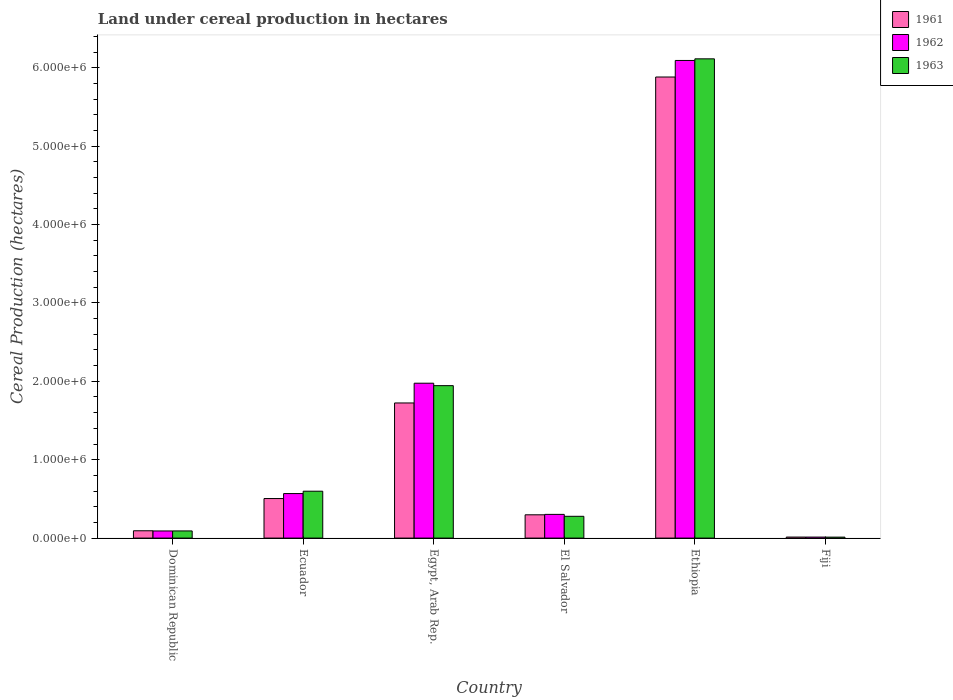How many different coloured bars are there?
Give a very brief answer. 3. Are the number of bars per tick equal to the number of legend labels?
Provide a succinct answer. Yes. Are the number of bars on each tick of the X-axis equal?
Give a very brief answer. Yes. How many bars are there on the 3rd tick from the right?
Provide a succinct answer. 3. What is the label of the 4th group of bars from the left?
Ensure brevity in your answer.  El Salvador. In how many cases, is the number of bars for a given country not equal to the number of legend labels?
Your answer should be compact. 0. What is the land under cereal production in 1963 in Ecuador?
Keep it short and to the point. 5.98e+05. Across all countries, what is the maximum land under cereal production in 1962?
Ensure brevity in your answer.  6.09e+06. Across all countries, what is the minimum land under cereal production in 1961?
Offer a very short reply. 1.31e+04. In which country was the land under cereal production in 1961 maximum?
Provide a short and direct response. Ethiopia. In which country was the land under cereal production in 1963 minimum?
Offer a terse response. Fiji. What is the total land under cereal production in 1963 in the graph?
Keep it short and to the point. 9.04e+06. What is the difference between the land under cereal production in 1963 in Dominican Republic and that in El Salvador?
Your answer should be very brief. -1.86e+05. What is the difference between the land under cereal production in 1961 in Ecuador and the land under cereal production in 1963 in El Salvador?
Offer a very short reply. 2.27e+05. What is the average land under cereal production in 1963 per country?
Offer a very short reply. 1.51e+06. What is the difference between the land under cereal production of/in 1961 and land under cereal production of/in 1962 in Ethiopia?
Ensure brevity in your answer.  -2.11e+05. In how many countries, is the land under cereal production in 1962 greater than 5000000 hectares?
Offer a terse response. 1. What is the ratio of the land under cereal production in 1963 in Egypt, Arab Rep. to that in El Salvador?
Give a very brief answer. 7. Is the land under cereal production in 1962 in Dominican Republic less than that in Egypt, Arab Rep.?
Provide a succinct answer. Yes. What is the difference between the highest and the second highest land under cereal production in 1963?
Your answer should be compact. -1.35e+06. What is the difference between the highest and the lowest land under cereal production in 1963?
Keep it short and to the point. 6.10e+06. Is the sum of the land under cereal production in 1962 in Ecuador and El Salvador greater than the maximum land under cereal production in 1961 across all countries?
Provide a short and direct response. No. How many countries are there in the graph?
Ensure brevity in your answer.  6. Does the graph contain grids?
Your response must be concise. No. Where does the legend appear in the graph?
Your answer should be compact. Top right. What is the title of the graph?
Your answer should be compact. Land under cereal production in hectares. Does "1985" appear as one of the legend labels in the graph?
Keep it short and to the point. No. What is the label or title of the Y-axis?
Ensure brevity in your answer.  Cereal Production (hectares). What is the Cereal Production (hectares) of 1961 in Dominican Republic?
Provide a succinct answer. 9.33e+04. What is the Cereal Production (hectares) in 1962 in Dominican Republic?
Give a very brief answer. 9.10e+04. What is the Cereal Production (hectares) of 1963 in Dominican Republic?
Your answer should be compact. 9.14e+04. What is the Cereal Production (hectares) in 1961 in Ecuador?
Keep it short and to the point. 5.05e+05. What is the Cereal Production (hectares) of 1962 in Ecuador?
Ensure brevity in your answer.  5.68e+05. What is the Cereal Production (hectares) of 1963 in Ecuador?
Offer a terse response. 5.98e+05. What is the Cereal Production (hectares) of 1961 in Egypt, Arab Rep.?
Ensure brevity in your answer.  1.72e+06. What is the Cereal Production (hectares) in 1962 in Egypt, Arab Rep.?
Ensure brevity in your answer.  1.98e+06. What is the Cereal Production (hectares) in 1963 in Egypt, Arab Rep.?
Offer a terse response. 1.94e+06. What is the Cereal Production (hectares) in 1961 in El Salvador?
Your response must be concise. 2.97e+05. What is the Cereal Production (hectares) of 1962 in El Salvador?
Offer a very short reply. 3.02e+05. What is the Cereal Production (hectares) in 1963 in El Salvador?
Your answer should be very brief. 2.78e+05. What is the Cereal Production (hectares) in 1961 in Ethiopia?
Your answer should be compact. 5.88e+06. What is the Cereal Production (hectares) in 1962 in Ethiopia?
Keep it short and to the point. 6.09e+06. What is the Cereal Production (hectares) in 1963 in Ethiopia?
Make the answer very short. 6.11e+06. What is the Cereal Production (hectares) of 1961 in Fiji?
Your answer should be compact. 1.31e+04. What is the Cereal Production (hectares) of 1962 in Fiji?
Offer a terse response. 1.29e+04. What is the Cereal Production (hectares) in 1963 in Fiji?
Your answer should be very brief. 1.23e+04. Across all countries, what is the maximum Cereal Production (hectares) in 1961?
Offer a very short reply. 5.88e+06. Across all countries, what is the maximum Cereal Production (hectares) of 1962?
Offer a terse response. 6.09e+06. Across all countries, what is the maximum Cereal Production (hectares) of 1963?
Your answer should be compact. 6.11e+06. Across all countries, what is the minimum Cereal Production (hectares) of 1961?
Your response must be concise. 1.31e+04. Across all countries, what is the minimum Cereal Production (hectares) in 1962?
Make the answer very short. 1.29e+04. Across all countries, what is the minimum Cereal Production (hectares) of 1963?
Give a very brief answer. 1.23e+04. What is the total Cereal Production (hectares) of 1961 in the graph?
Offer a terse response. 8.51e+06. What is the total Cereal Production (hectares) in 1962 in the graph?
Offer a terse response. 9.04e+06. What is the total Cereal Production (hectares) of 1963 in the graph?
Your response must be concise. 9.04e+06. What is the difference between the Cereal Production (hectares) of 1961 in Dominican Republic and that in Ecuador?
Give a very brief answer. -4.11e+05. What is the difference between the Cereal Production (hectares) of 1962 in Dominican Republic and that in Ecuador?
Offer a very short reply. -4.77e+05. What is the difference between the Cereal Production (hectares) of 1963 in Dominican Republic and that in Ecuador?
Your answer should be compact. -5.07e+05. What is the difference between the Cereal Production (hectares) in 1961 in Dominican Republic and that in Egypt, Arab Rep.?
Provide a succinct answer. -1.63e+06. What is the difference between the Cereal Production (hectares) of 1962 in Dominican Republic and that in Egypt, Arab Rep.?
Keep it short and to the point. -1.88e+06. What is the difference between the Cereal Production (hectares) in 1963 in Dominican Republic and that in Egypt, Arab Rep.?
Keep it short and to the point. -1.85e+06. What is the difference between the Cereal Production (hectares) in 1961 in Dominican Republic and that in El Salvador?
Your response must be concise. -2.04e+05. What is the difference between the Cereal Production (hectares) in 1962 in Dominican Republic and that in El Salvador?
Your answer should be very brief. -2.11e+05. What is the difference between the Cereal Production (hectares) of 1963 in Dominican Republic and that in El Salvador?
Offer a terse response. -1.86e+05. What is the difference between the Cereal Production (hectares) in 1961 in Dominican Republic and that in Ethiopia?
Ensure brevity in your answer.  -5.79e+06. What is the difference between the Cereal Production (hectares) in 1962 in Dominican Republic and that in Ethiopia?
Provide a succinct answer. -6.00e+06. What is the difference between the Cereal Production (hectares) of 1963 in Dominican Republic and that in Ethiopia?
Ensure brevity in your answer.  -6.02e+06. What is the difference between the Cereal Production (hectares) of 1961 in Dominican Republic and that in Fiji?
Your answer should be very brief. 8.03e+04. What is the difference between the Cereal Production (hectares) in 1962 in Dominican Republic and that in Fiji?
Make the answer very short. 7.81e+04. What is the difference between the Cereal Production (hectares) of 1963 in Dominican Republic and that in Fiji?
Provide a succinct answer. 7.91e+04. What is the difference between the Cereal Production (hectares) in 1961 in Ecuador and that in Egypt, Arab Rep.?
Your response must be concise. -1.22e+06. What is the difference between the Cereal Production (hectares) of 1962 in Ecuador and that in Egypt, Arab Rep.?
Provide a short and direct response. -1.41e+06. What is the difference between the Cereal Production (hectares) of 1963 in Ecuador and that in Egypt, Arab Rep.?
Offer a terse response. -1.35e+06. What is the difference between the Cereal Production (hectares) in 1961 in Ecuador and that in El Salvador?
Your answer should be very brief. 2.07e+05. What is the difference between the Cereal Production (hectares) in 1962 in Ecuador and that in El Salvador?
Your answer should be very brief. 2.66e+05. What is the difference between the Cereal Production (hectares) in 1963 in Ecuador and that in El Salvador?
Make the answer very short. 3.20e+05. What is the difference between the Cereal Production (hectares) in 1961 in Ecuador and that in Ethiopia?
Provide a succinct answer. -5.38e+06. What is the difference between the Cereal Production (hectares) in 1962 in Ecuador and that in Ethiopia?
Provide a succinct answer. -5.53e+06. What is the difference between the Cereal Production (hectares) of 1963 in Ecuador and that in Ethiopia?
Ensure brevity in your answer.  -5.52e+06. What is the difference between the Cereal Production (hectares) in 1961 in Ecuador and that in Fiji?
Provide a short and direct response. 4.91e+05. What is the difference between the Cereal Production (hectares) of 1962 in Ecuador and that in Fiji?
Give a very brief answer. 5.55e+05. What is the difference between the Cereal Production (hectares) of 1963 in Ecuador and that in Fiji?
Provide a succinct answer. 5.86e+05. What is the difference between the Cereal Production (hectares) of 1961 in Egypt, Arab Rep. and that in El Salvador?
Your response must be concise. 1.43e+06. What is the difference between the Cereal Production (hectares) in 1962 in Egypt, Arab Rep. and that in El Salvador?
Your answer should be very brief. 1.67e+06. What is the difference between the Cereal Production (hectares) in 1963 in Egypt, Arab Rep. and that in El Salvador?
Your answer should be very brief. 1.67e+06. What is the difference between the Cereal Production (hectares) of 1961 in Egypt, Arab Rep. and that in Ethiopia?
Your answer should be compact. -4.16e+06. What is the difference between the Cereal Production (hectares) of 1962 in Egypt, Arab Rep. and that in Ethiopia?
Your answer should be very brief. -4.12e+06. What is the difference between the Cereal Production (hectares) of 1963 in Egypt, Arab Rep. and that in Ethiopia?
Keep it short and to the point. -4.17e+06. What is the difference between the Cereal Production (hectares) of 1961 in Egypt, Arab Rep. and that in Fiji?
Ensure brevity in your answer.  1.71e+06. What is the difference between the Cereal Production (hectares) in 1962 in Egypt, Arab Rep. and that in Fiji?
Ensure brevity in your answer.  1.96e+06. What is the difference between the Cereal Production (hectares) in 1963 in Egypt, Arab Rep. and that in Fiji?
Keep it short and to the point. 1.93e+06. What is the difference between the Cereal Production (hectares) in 1961 in El Salvador and that in Ethiopia?
Ensure brevity in your answer.  -5.58e+06. What is the difference between the Cereal Production (hectares) of 1962 in El Salvador and that in Ethiopia?
Your answer should be very brief. -5.79e+06. What is the difference between the Cereal Production (hectares) of 1963 in El Salvador and that in Ethiopia?
Your answer should be compact. -5.84e+06. What is the difference between the Cereal Production (hectares) of 1961 in El Salvador and that in Fiji?
Your response must be concise. 2.84e+05. What is the difference between the Cereal Production (hectares) in 1962 in El Salvador and that in Fiji?
Offer a very short reply. 2.90e+05. What is the difference between the Cereal Production (hectares) of 1963 in El Salvador and that in Fiji?
Provide a succinct answer. 2.66e+05. What is the difference between the Cereal Production (hectares) of 1961 in Ethiopia and that in Fiji?
Your answer should be very brief. 5.87e+06. What is the difference between the Cereal Production (hectares) of 1962 in Ethiopia and that in Fiji?
Ensure brevity in your answer.  6.08e+06. What is the difference between the Cereal Production (hectares) of 1963 in Ethiopia and that in Fiji?
Your response must be concise. 6.10e+06. What is the difference between the Cereal Production (hectares) in 1961 in Dominican Republic and the Cereal Production (hectares) in 1962 in Ecuador?
Provide a short and direct response. -4.75e+05. What is the difference between the Cereal Production (hectares) in 1961 in Dominican Republic and the Cereal Production (hectares) in 1963 in Ecuador?
Offer a terse response. -5.05e+05. What is the difference between the Cereal Production (hectares) of 1962 in Dominican Republic and the Cereal Production (hectares) of 1963 in Ecuador?
Make the answer very short. -5.07e+05. What is the difference between the Cereal Production (hectares) of 1961 in Dominican Republic and the Cereal Production (hectares) of 1962 in Egypt, Arab Rep.?
Provide a short and direct response. -1.88e+06. What is the difference between the Cereal Production (hectares) of 1961 in Dominican Republic and the Cereal Production (hectares) of 1963 in Egypt, Arab Rep.?
Provide a short and direct response. -1.85e+06. What is the difference between the Cereal Production (hectares) in 1962 in Dominican Republic and the Cereal Production (hectares) in 1963 in Egypt, Arab Rep.?
Your answer should be very brief. -1.85e+06. What is the difference between the Cereal Production (hectares) of 1961 in Dominican Republic and the Cereal Production (hectares) of 1962 in El Salvador?
Give a very brief answer. -2.09e+05. What is the difference between the Cereal Production (hectares) in 1961 in Dominican Republic and the Cereal Production (hectares) in 1963 in El Salvador?
Provide a succinct answer. -1.85e+05. What is the difference between the Cereal Production (hectares) of 1962 in Dominican Republic and the Cereal Production (hectares) of 1963 in El Salvador?
Offer a very short reply. -1.87e+05. What is the difference between the Cereal Production (hectares) of 1961 in Dominican Republic and the Cereal Production (hectares) of 1962 in Ethiopia?
Provide a short and direct response. -6.00e+06. What is the difference between the Cereal Production (hectares) in 1961 in Dominican Republic and the Cereal Production (hectares) in 1963 in Ethiopia?
Provide a short and direct response. -6.02e+06. What is the difference between the Cereal Production (hectares) in 1962 in Dominican Republic and the Cereal Production (hectares) in 1963 in Ethiopia?
Provide a succinct answer. -6.02e+06. What is the difference between the Cereal Production (hectares) in 1961 in Dominican Republic and the Cereal Production (hectares) in 1962 in Fiji?
Ensure brevity in your answer.  8.05e+04. What is the difference between the Cereal Production (hectares) in 1961 in Dominican Republic and the Cereal Production (hectares) in 1963 in Fiji?
Your response must be concise. 8.11e+04. What is the difference between the Cereal Production (hectares) of 1962 in Dominican Republic and the Cereal Production (hectares) of 1963 in Fiji?
Give a very brief answer. 7.87e+04. What is the difference between the Cereal Production (hectares) in 1961 in Ecuador and the Cereal Production (hectares) in 1962 in Egypt, Arab Rep.?
Make the answer very short. -1.47e+06. What is the difference between the Cereal Production (hectares) of 1961 in Ecuador and the Cereal Production (hectares) of 1963 in Egypt, Arab Rep.?
Provide a short and direct response. -1.44e+06. What is the difference between the Cereal Production (hectares) of 1962 in Ecuador and the Cereal Production (hectares) of 1963 in Egypt, Arab Rep.?
Keep it short and to the point. -1.38e+06. What is the difference between the Cereal Production (hectares) of 1961 in Ecuador and the Cereal Production (hectares) of 1962 in El Salvador?
Offer a very short reply. 2.02e+05. What is the difference between the Cereal Production (hectares) of 1961 in Ecuador and the Cereal Production (hectares) of 1963 in El Salvador?
Offer a very short reply. 2.27e+05. What is the difference between the Cereal Production (hectares) in 1962 in Ecuador and the Cereal Production (hectares) in 1963 in El Salvador?
Offer a terse response. 2.90e+05. What is the difference between the Cereal Production (hectares) in 1961 in Ecuador and the Cereal Production (hectares) in 1962 in Ethiopia?
Your answer should be very brief. -5.59e+06. What is the difference between the Cereal Production (hectares) of 1961 in Ecuador and the Cereal Production (hectares) of 1963 in Ethiopia?
Provide a succinct answer. -5.61e+06. What is the difference between the Cereal Production (hectares) of 1962 in Ecuador and the Cereal Production (hectares) of 1963 in Ethiopia?
Your answer should be very brief. -5.55e+06. What is the difference between the Cereal Production (hectares) of 1961 in Ecuador and the Cereal Production (hectares) of 1962 in Fiji?
Your response must be concise. 4.92e+05. What is the difference between the Cereal Production (hectares) of 1961 in Ecuador and the Cereal Production (hectares) of 1963 in Fiji?
Make the answer very short. 4.92e+05. What is the difference between the Cereal Production (hectares) in 1962 in Ecuador and the Cereal Production (hectares) in 1963 in Fiji?
Provide a succinct answer. 5.56e+05. What is the difference between the Cereal Production (hectares) in 1961 in Egypt, Arab Rep. and the Cereal Production (hectares) in 1962 in El Salvador?
Offer a very short reply. 1.42e+06. What is the difference between the Cereal Production (hectares) of 1961 in Egypt, Arab Rep. and the Cereal Production (hectares) of 1963 in El Salvador?
Make the answer very short. 1.45e+06. What is the difference between the Cereal Production (hectares) in 1962 in Egypt, Arab Rep. and the Cereal Production (hectares) in 1963 in El Salvador?
Offer a terse response. 1.70e+06. What is the difference between the Cereal Production (hectares) of 1961 in Egypt, Arab Rep. and the Cereal Production (hectares) of 1962 in Ethiopia?
Provide a succinct answer. -4.37e+06. What is the difference between the Cereal Production (hectares) in 1961 in Egypt, Arab Rep. and the Cereal Production (hectares) in 1963 in Ethiopia?
Offer a very short reply. -4.39e+06. What is the difference between the Cereal Production (hectares) in 1962 in Egypt, Arab Rep. and the Cereal Production (hectares) in 1963 in Ethiopia?
Offer a terse response. -4.14e+06. What is the difference between the Cereal Production (hectares) in 1961 in Egypt, Arab Rep. and the Cereal Production (hectares) in 1962 in Fiji?
Your answer should be very brief. 1.71e+06. What is the difference between the Cereal Production (hectares) of 1961 in Egypt, Arab Rep. and the Cereal Production (hectares) of 1963 in Fiji?
Your answer should be compact. 1.71e+06. What is the difference between the Cereal Production (hectares) of 1962 in Egypt, Arab Rep. and the Cereal Production (hectares) of 1963 in Fiji?
Make the answer very short. 1.96e+06. What is the difference between the Cereal Production (hectares) of 1961 in El Salvador and the Cereal Production (hectares) of 1962 in Ethiopia?
Provide a succinct answer. -5.80e+06. What is the difference between the Cereal Production (hectares) in 1961 in El Salvador and the Cereal Production (hectares) in 1963 in Ethiopia?
Give a very brief answer. -5.82e+06. What is the difference between the Cereal Production (hectares) of 1962 in El Salvador and the Cereal Production (hectares) of 1963 in Ethiopia?
Your answer should be very brief. -5.81e+06. What is the difference between the Cereal Production (hectares) of 1961 in El Salvador and the Cereal Production (hectares) of 1962 in Fiji?
Keep it short and to the point. 2.84e+05. What is the difference between the Cereal Production (hectares) of 1961 in El Salvador and the Cereal Production (hectares) of 1963 in Fiji?
Your answer should be very brief. 2.85e+05. What is the difference between the Cereal Production (hectares) of 1962 in El Salvador and the Cereal Production (hectares) of 1963 in Fiji?
Ensure brevity in your answer.  2.90e+05. What is the difference between the Cereal Production (hectares) of 1961 in Ethiopia and the Cereal Production (hectares) of 1962 in Fiji?
Provide a succinct answer. 5.87e+06. What is the difference between the Cereal Production (hectares) in 1961 in Ethiopia and the Cereal Production (hectares) in 1963 in Fiji?
Provide a short and direct response. 5.87e+06. What is the difference between the Cereal Production (hectares) of 1962 in Ethiopia and the Cereal Production (hectares) of 1963 in Fiji?
Provide a short and direct response. 6.08e+06. What is the average Cereal Production (hectares) of 1961 per country?
Provide a succinct answer. 1.42e+06. What is the average Cereal Production (hectares) of 1962 per country?
Provide a short and direct response. 1.51e+06. What is the average Cereal Production (hectares) in 1963 per country?
Your answer should be very brief. 1.51e+06. What is the difference between the Cereal Production (hectares) of 1961 and Cereal Production (hectares) of 1962 in Dominican Republic?
Provide a short and direct response. 2320. What is the difference between the Cereal Production (hectares) of 1961 and Cereal Production (hectares) of 1963 in Dominican Republic?
Your response must be concise. 1920. What is the difference between the Cereal Production (hectares) in 1962 and Cereal Production (hectares) in 1963 in Dominican Republic?
Keep it short and to the point. -400. What is the difference between the Cereal Production (hectares) of 1961 and Cereal Production (hectares) of 1962 in Ecuador?
Keep it short and to the point. -6.34e+04. What is the difference between the Cereal Production (hectares) of 1961 and Cereal Production (hectares) of 1963 in Ecuador?
Your answer should be very brief. -9.35e+04. What is the difference between the Cereal Production (hectares) of 1962 and Cereal Production (hectares) of 1963 in Ecuador?
Offer a terse response. -3.01e+04. What is the difference between the Cereal Production (hectares) of 1961 and Cereal Production (hectares) of 1962 in Egypt, Arab Rep.?
Provide a short and direct response. -2.52e+05. What is the difference between the Cereal Production (hectares) in 1961 and Cereal Production (hectares) in 1963 in Egypt, Arab Rep.?
Make the answer very short. -2.21e+05. What is the difference between the Cereal Production (hectares) in 1962 and Cereal Production (hectares) in 1963 in Egypt, Arab Rep.?
Ensure brevity in your answer.  3.10e+04. What is the difference between the Cereal Production (hectares) in 1961 and Cereal Production (hectares) in 1962 in El Salvador?
Provide a succinct answer. -5375. What is the difference between the Cereal Production (hectares) in 1961 and Cereal Production (hectares) in 1963 in El Salvador?
Make the answer very short. 1.92e+04. What is the difference between the Cereal Production (hectares) of 1962 and Cereal Production (hectares) of 1963 in El Salvador?
Your response must be concise. 2.46e+04. What is the difference between the Cereal Production (hectares) in 1961 and Cereal Production (hectares) in 1962 in Ethiopia?
Offer a terse response. -2.11e+05. What is the difference between the Cereal Production (hectares) of 1961 and Cereal Production (hectares) of 1963 in Ethiopia?
Your answer should be very brief. -2.32e+05. What is the difference between the Cereal Production (hectares) of 1962 and Cereal Production (hectares) of 1963 in Ethiopia?
Give a very brief answer. -2.07e+04. What is the difference between the Cereal Production (hectares) of 1961 and Cereal Production (hectares) of 1962 in Fiji?
Provide a short and direct response. 203. What is the difference between the Cereal Production (hectares) of 1961 and Cereal Production (hectares) of 1963 in Fiji?
Make the answer very short. 797. What is the difference between the Cereal Production (hectares) of 1962 and Cereal Production (hectares) of 1963 in Fiji?
Offer a very short reply. 594. What is the ratio of the Cereal Production (hectares) in 1961 in Dominican Republic to that in Ecuador?
Keep it short and to the point. 0.18. What is the ratio of the Cereal Production (hectares) in 1962 in Dominican Republic to that in Ecuador?
Offer a very short reply. 0.16. What is the ratio of the Cereal Production (hectares) in 1963 in Dominican Republic to that in Ecuador?
Give a very brief answer. 0.15. What is the ratio of the Cereal Production (hectares) in 1961 in Dominican Republic to that in Egypt, Arab Rep.?
Your answer should be very brief. 0.05. What is the ratio of the Cereal Production (hectares) in 1962 in Dominican Republic to that in Egypt, Arab Rep.?
Your response must be concise. 0.05. What is the ratio of the Cereal Production (hectares) in 1963 in Dominican Republic to that in Egypt, Arab Rep.?
Your answer should be very brief. 0.05. What is the ratio of the Cereal Production (hectares) of 1961 in Dominican Republic to that in El Salvador?
Offer a very short reply. 0.31. What is the ratio of the Cereal Production (hectares) of 1962 in Dominican Republic to that in El Salvador?
Ensure brevity in your answer.  0.3. What is the ratio of the Cereal Production (hectares) of 1963 in Dominican Republic to that in El Salvador?
Make the answer very short. 0.33. What is the ratio of the Cereal Production (hectares) in 1961 in Dominican Republic to that in Ethiopia?
Provide a short and direct response. 0.02. What is the ratio of the Cereal Production (hectares) in 1962 in Dominican Republic to that in Ethiopia?
Give a very brief answer. 0.01. What is the ratio of the Cereal Production (hectares) in 1963 in Dominican Republic to that in Ethiopia?
Give a very brief answer. 0.01. What is the ratio of the Cereal Production (hectares) in 1961 in Dominican Republic to that in Fiji?
Offer a very short reply. 7.15. What is the ratio of the Cereal Production (hectares) in 1962 in Dominican Republic to that in Fiji?
Your answer should be very brief. 7.08. What is the ratio of the Cereal Production (hectares) of 1963 in Dominican Republic to that in Fiji?
Your answer should be very brief. 7.45. What is the ratio of the Cereal Production (hectares) of 1961 in Ecuador to that in Egypt, Arab Rep.?
Make the answer very short. 0.29. What is the ratio of the Cereal Production (hectares) of 1962 in Ecuador to that in Egypt, Arab Rep.?
Give a very brief answer. 0.29. What is the ratio of the Cereal Production (hectares) of 1963 in Ecuador to that in Egypt, Arab Rep.?
Make the answer very short. 0.31. What is the ratio of the Cereal Production (hectares) in 1961 in Ecuador to that in El Salvador?
Offer a very short reply. 1.7. What is the ratio of the Cereal Production (hectares) in 1962 in Ecuador to that in El Salvador?
Make the answer very short. 1.88. What is the ratio of the Cereal Production (hectares) in 1963 in Ecuador to that in El Salvador?
Offer a very short reply. 2.15. What is the ratio of the Cereal Production (hectares) in 1961 in Ecuador to that in Ethiopia?
Provide a succinct answer. 0.09. What is the ratio of the Cereal Production (hectares) of 1962 in Ecuador to that in Ethiopia?
Keep it short and to the point. 0.09. What is the ratio of the Cereal Production (hectares) in 1963 in Ecuador to that in Ethiopia?
Make the answer very short. 0.1. What is the ratio of the Cereal Production (hectares) in 1961 in Ecuador to that in Fiji?
Offer a very short reply. 38.63. What is the ratio of the Cereal Production (hectares) of 1962 in Ecuador to that in Fiji?
Your response must be concise. 44.18. What is the ratio of the Cereal Production (hectares) in 1963 in Ecuador to that in Fiji?
Ensure brevity in your answer.  48.77. What is the ratio of the Cereal Production (hectares) in 1961 in Egypt, Arab Rep. to that in El Salvador?
Give a very brief answer. 5.8. What is the ratio of the Cereal Production (hectares) in 1962 in Egypt, Arab Rep. to that in El Salvador?
Your answer should be very brief. 6.53. What is the ratio of the Cereal Production (hectares) of 1963 in Egypt, Arab Rep. to that in El Salvador?
Ensure brevity in your answer.  7. What is the ratio of the Cereal Production (hectares) of 1961 in Egypt, Arab Rep. to that in Ethiopia?
Your response must be concise. 0.29. What is the ratio of the Cereal Production (hectares) of 1962 in Egypt, Arab Rep. to that in Ethiopia?
Your answer should be very brief. 0.32. What is the ratio of the Cereal Production (hectares) in 1963 in Egypt, Arab Rep. to that in Ethiopia?
Your answer should be very brief. 0.32. What is the ratio of the Cereal Production (hectares) of 1961 in Egypt, Arab Rep. to that in Fiji?
Make the answer very short. 131.99. What is the ratio of the Cereal Production (hectares) in 1962 in Egypt, Arab Rep. to that in Fiji?
Offer a very short reply. 153.67. What is the ratio of the Cereal Production (hectares) in 1963 in Egypt, Arab Rep. to that in Fiji?
Offer a terse response. 158.58. What is the ratio of the Cereal Production (hectares) in 1961 in El Salvador to that in Ethiopia?
Ensure brevity in your answer.  0.05. What is the ratio of the Cereal Production (hectares) of 1962 in El Salvador to that in Ethiopia?
Offer a very short reply. 0.05. What is the ratio of the Cereal Production (hectares) in 1963 in El Salvador to that in Ethiopia?
Provide a short and direct response. 0.05. What is the ratio of the Cereal Production (hectares) of 1961 in El Salvador to that in Fiji?
Make the answer very short. 22.75. What is the ratio of the Cereal Production (hectares) in 1962 in El Salvador to that in Fiji?
Your response must be concise. 23.53. What is the ratio of the Cereal Production (hectares) in 1963 in El Salvador to that in Fiji?
Give a very brief answer. 22.66. What is the ratio of the Cereal Production (hectares) of 1961 in Ethiopia to that in Fiji?
Ensure brevity in your answer.  450.38. What is the ratio of the Cereal Production (hectares) of 1962 in Ethiopia to that in Fiji?
Ensure brevity in your answer.  473.91. What is the ratio of the Cereal Production (hectares) of 1963 in Ethiopia to that in Fiji?
Provide a succinct answer. 498.55. What is the difference between the highest and the second highest Cereal Production (hectares) of 1961?
Offer a terse response. 4.16e+06. What is the difference between the highest and the second highest Cereal Production (hectares) in 1962?
Your response must be concise. 4.12e+06. What is the difference between the highest and the second highest Cereal Production (hectares) of 1963?
Ensure brevity in your answer.  4.17e+06. What is the difference between the highest and the lowest Cereal Production (hectares) in 1961?
Your response must be concise. 5.87e+06. What is the difference between the highest and the lowest Cereal Production (hectares) in 1962?
Your answer should be compact. 6.08e+06. What is the difference between the highest and the lowest Cereal Production (hectares) of 1963?
Your response must be concise. 6.10e+06. 